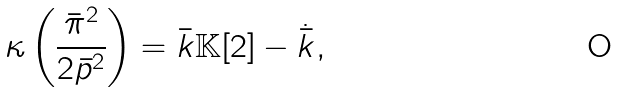<formula> <loc_0><loc_0><loc_500><loc_500>\kappa \left ( \frac { \bar { \pi } ^ { 2 } } { 2 \bar { p } ^ { 2 } } \right ) = \bar { k } \mathbb { K } [ 2 ] - \dot { \bar { k } } ,</formula> 